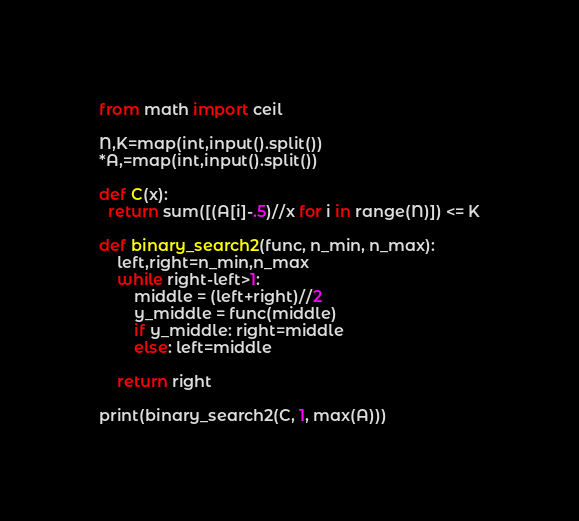<code> <loc_0><loc_0><loc_500><loc_500><_Python_>from math import ceil

N,K=map(int,input().split())
*A,=map(int,input().split())

def C(x):
  return sum([(A[i]-.5)//x for i in range(N)]) <= K
  
def binary_search2(func, n_min, n_max):
    left,right=n_min,n_max
    while right-left>1:
        middle = (left+right)//2
        y_middle = func(middle)
        if y_middle: right=middle
        else: left=middle

    return right
  
print(binary_search2(C, 1, max(A)))</code> 